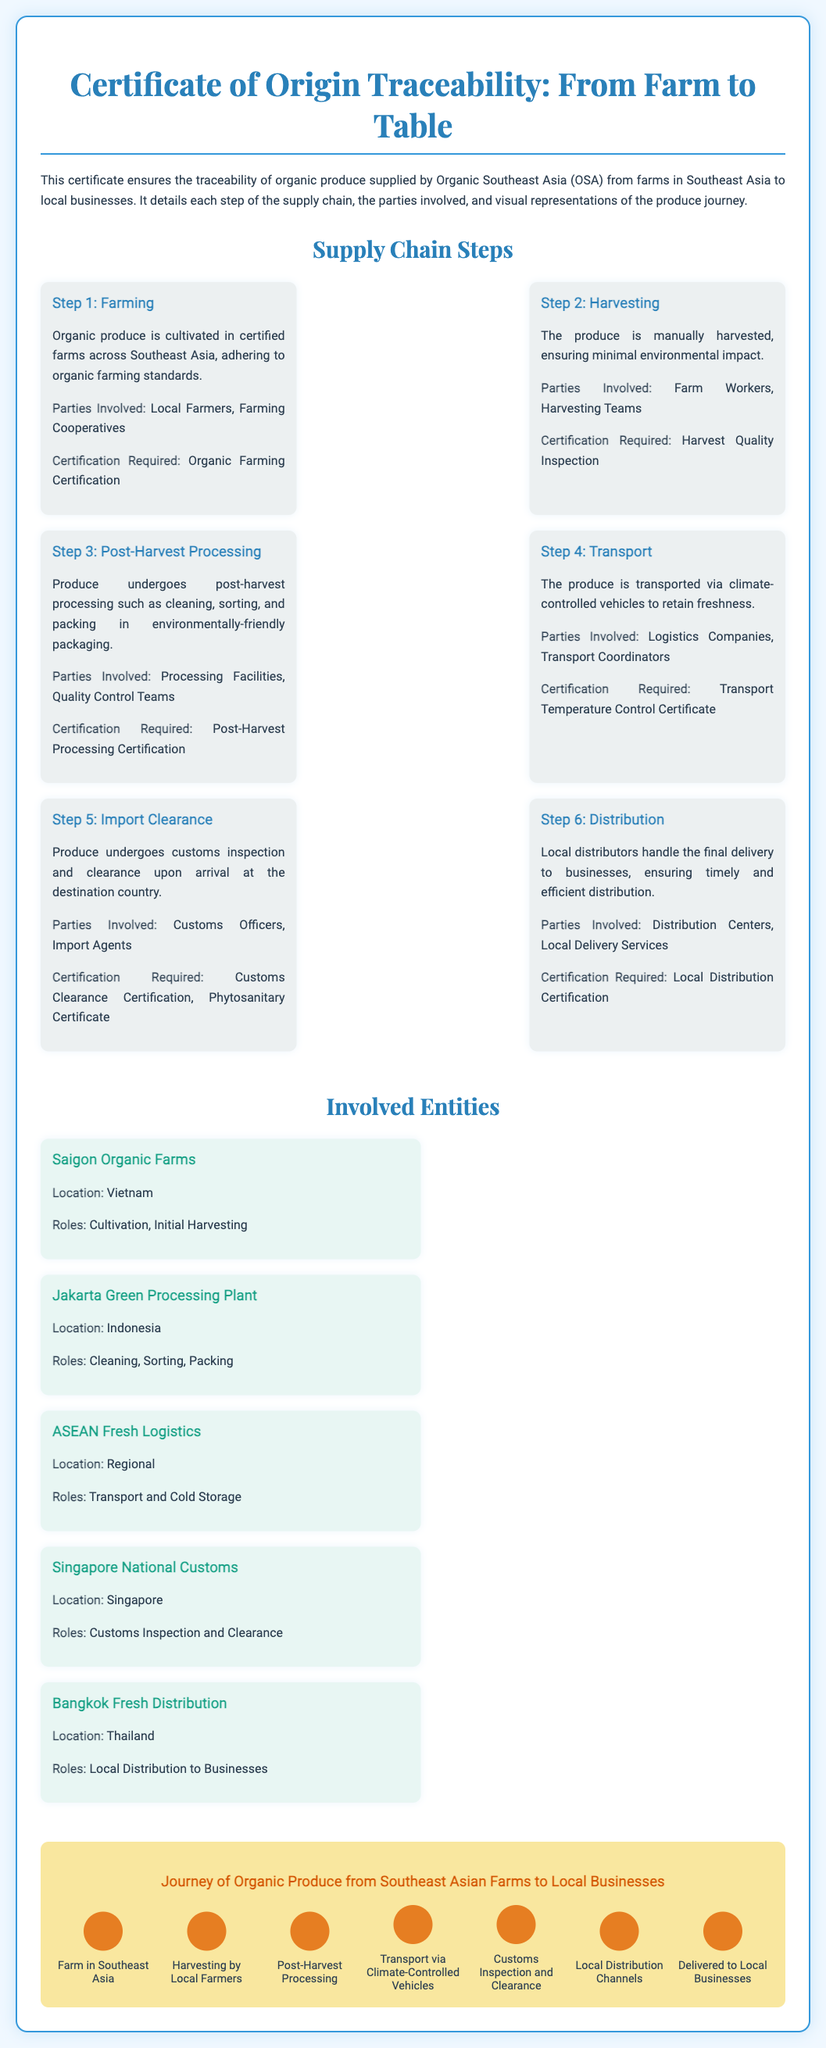What is the title of the certificate? The title appears at the top of the document, indicating the focus of the certification.
Answer: Certificate of Origin Traceability: From Farm to Table Which step involves manual harvesting? This detail is specified in the supply chain steps, pinpointing where manual labor is utilized.
Answer: Step 2: Harvesting What is the certification required for post-harvest processing? The document lists the necessary certifications for each step, providing clear information on what is needed in this context.
Answer: Post-Harvest Processing Certification Who is responsible for customs inspection in Singapore? The involved entities section outlines the roles each party plays, identifying those responsible for inspection.
Answer: Singapore National Customs What type of vehicles are used for transport? The transport step describes the vehicles employed to ensure produce freshness.
Answer: Climate-controlled vehicles Which country is the Jakarta Green Processing Plant located in? The location of each entity is listed, specifying where they operate.
Answer: Indonesia How many steps are involved in the supply chain? A count of the steps presented will yield an understanding of the complexity of the supply chain.
Answer: Six steps What role does Bangkok Fresh Distribution play? The role of this entity is clearly stated in the entities section, identifying its responsibilities in the supply chain.
Answer: Local Distribution to Businesses 